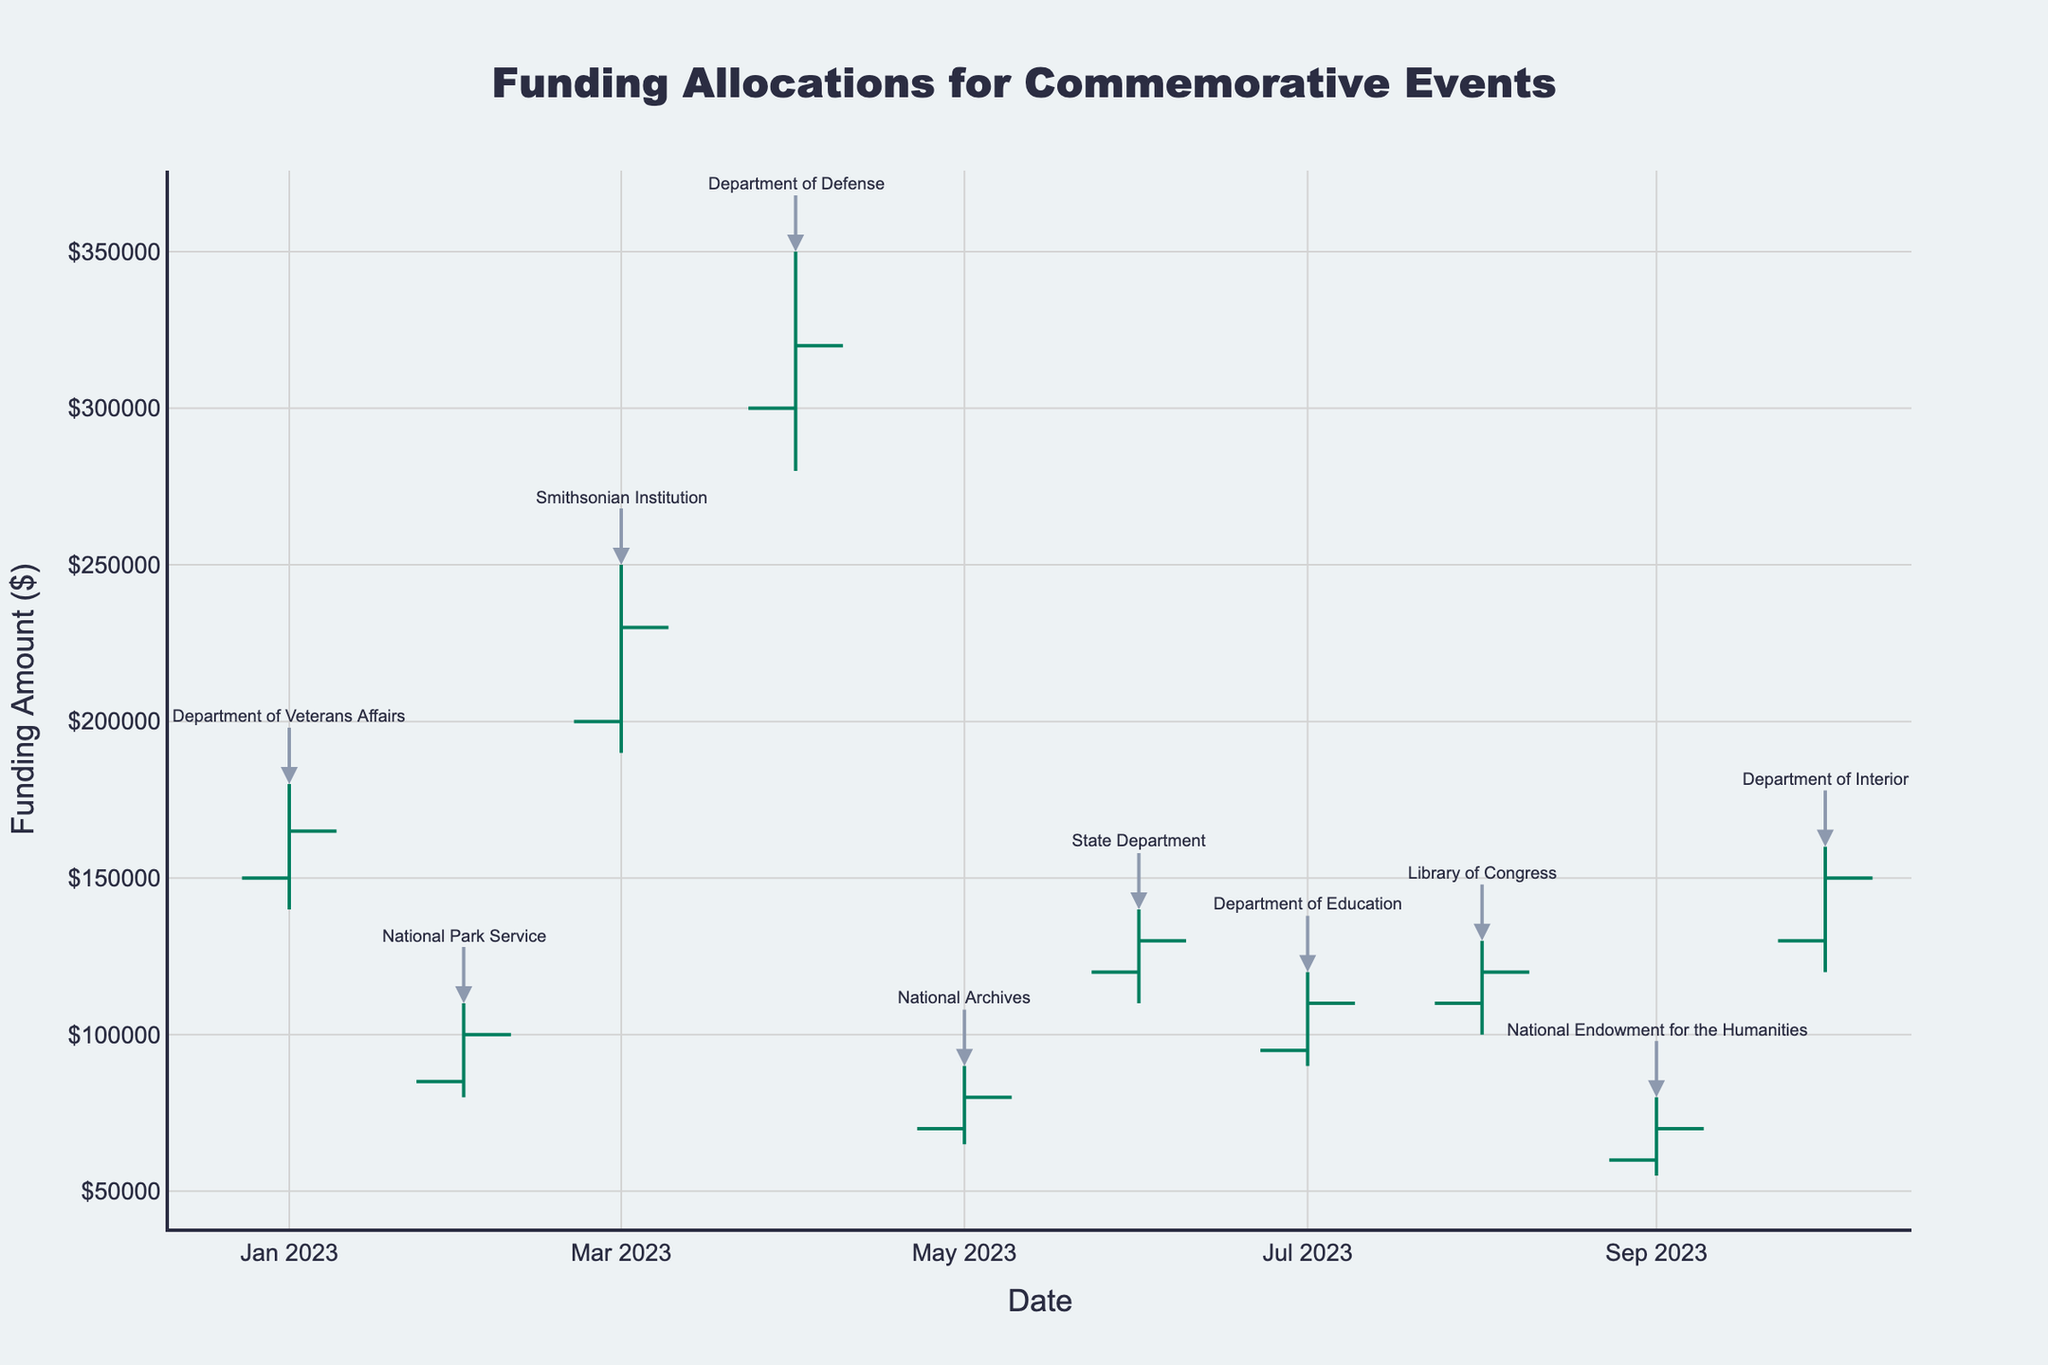How many departments are represented in the chart? Count the number of unique department names listed as annotations on the chart.
Answer: 10 What is the highest funding allocation observed in the chart? Look for the highest 'High' value on the y-axis across all data points. In this case, it is for the Smithsonian Institution at $250,000.
Answer: $250,000 Which department had the lowest funding at close in their respective allocation period? Identify the 'Close' values for each department and find the lowest. The National Endowment for the Humanities closed at $70,000.
Answer: National Endowment for the Humanities What was the range of funding for the Department of Defense in April 2023? The range is calculated as the difference between the 'High' and 'Low' values for the Department of Defense in April 2023: $350,000 - $280,000.
Answer: $70,000 Which departments had funding allocations that both opened and closed above $100,000? Compare the 'Open' and 'Close' values for each department to see which are both above $100,000. The departments are Department of Veterans Affairs, Smithsonian Institution, Department of Defense, State Department, Department of Education, Library of Congress, and Department of Interior.
Answer: 7 departments What is the average closing allocation across all departments? Sum all the 'Close' values and divide by the number of departments: ($165,000 + $100,000 + $230,000 + $320,000 + $80,000 + $130,000 + $110,000 + $120,000 + $70,000 + $150,000) / 10.
Answer: $147,500 Which month and department saw the highest increase from open to close? Calculate the difference between 'Open' and 'Close' for each department and find the maximum increase. The Smithsonian Institution in March 2023 saw an increase from $200,000 to $230,000, an increase of $30,000.
Answer: March 2023, Smithsonian Institution Did any department have a funding allocation where the opening, high, and closing amounts were all above $200,000? Examine each department's 'Open', 'High', and 'Close' values to determine if they all exceed $200,000. Only the Smithsonian Institution's funding allocation in March 2023 meets this criterion.
Answer: Yes, Smithsonian Institution 